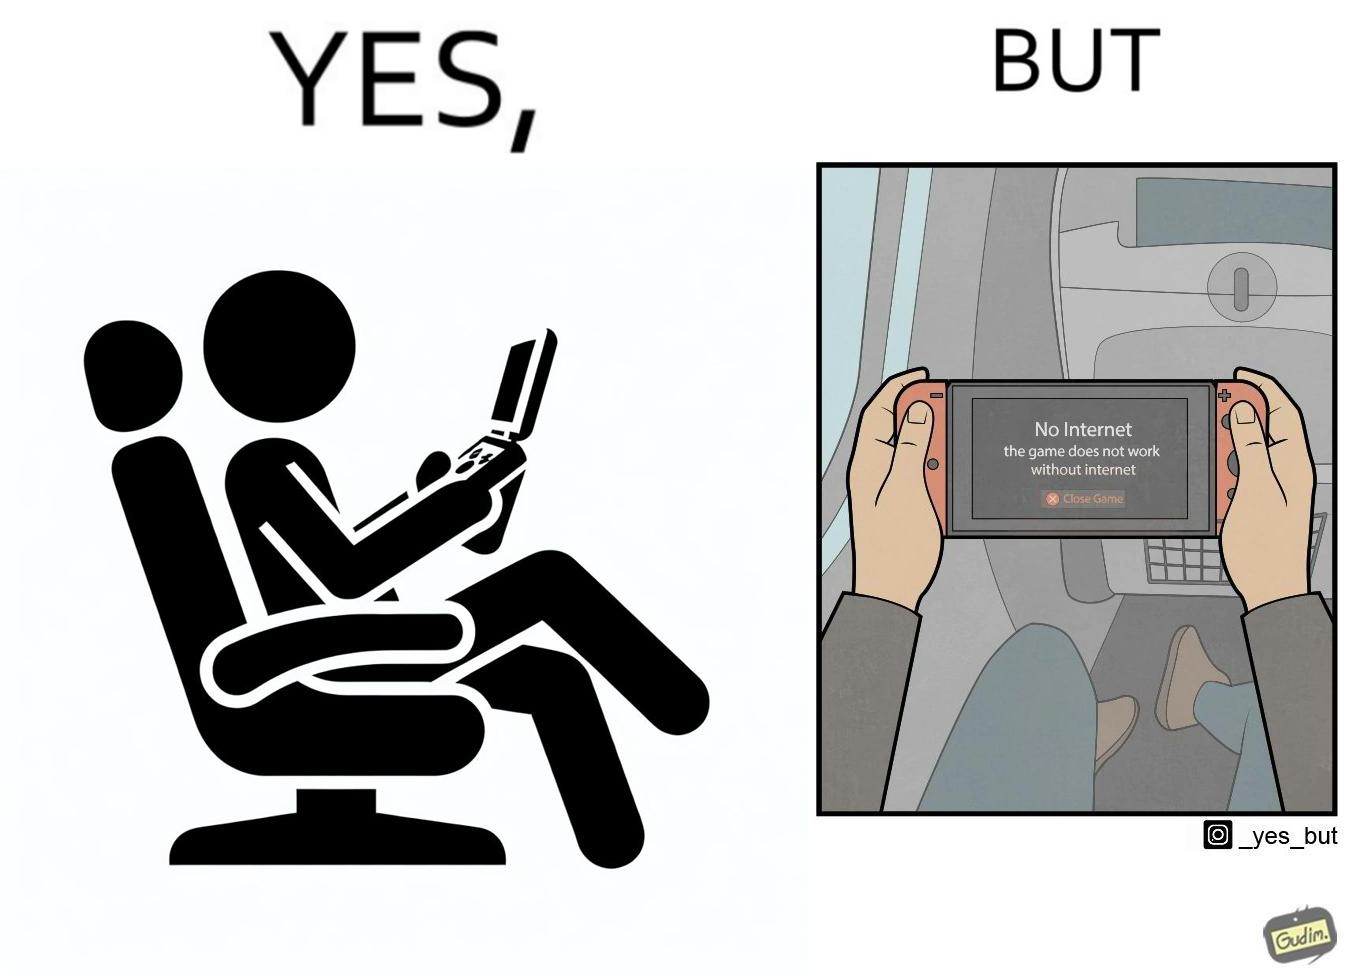Would you classify this image as satirical? Yes, this image is satirical. 